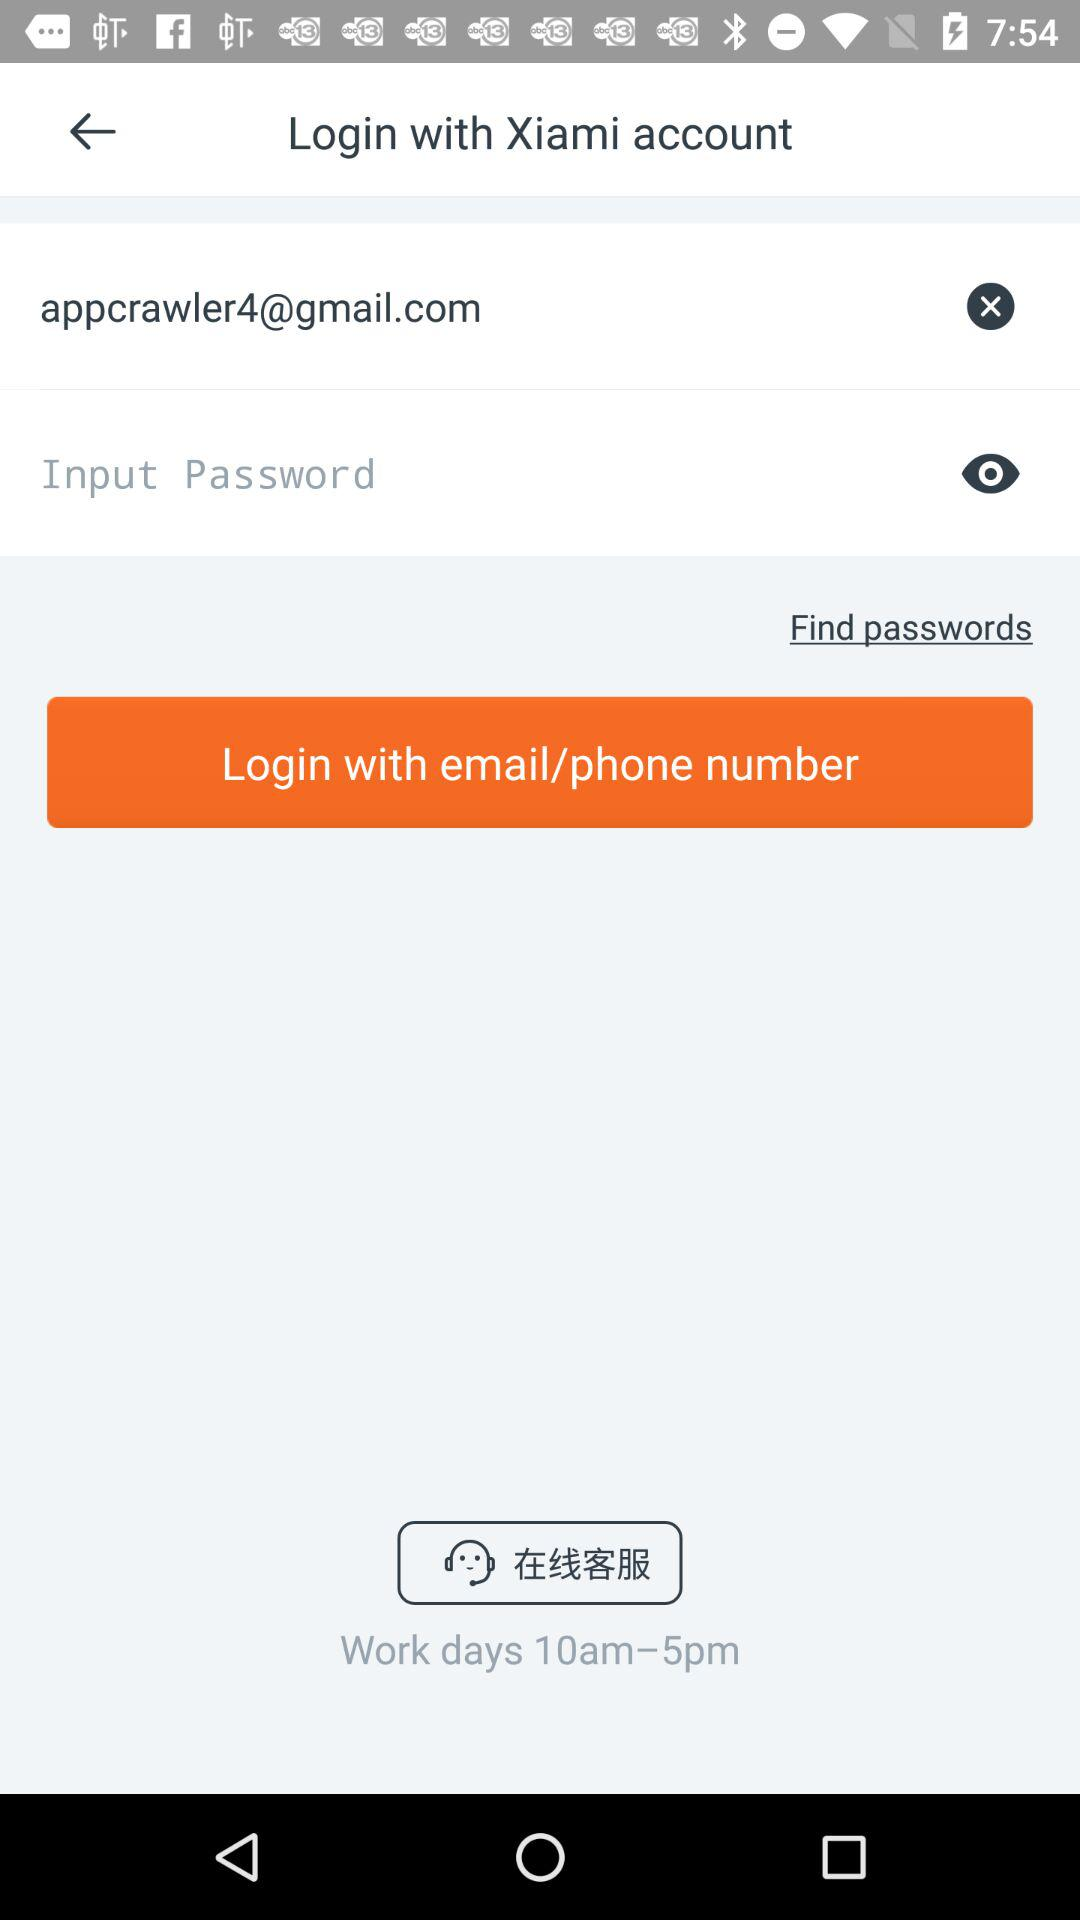What are the timings of workdays? The timings are 10 am–5 pm. 